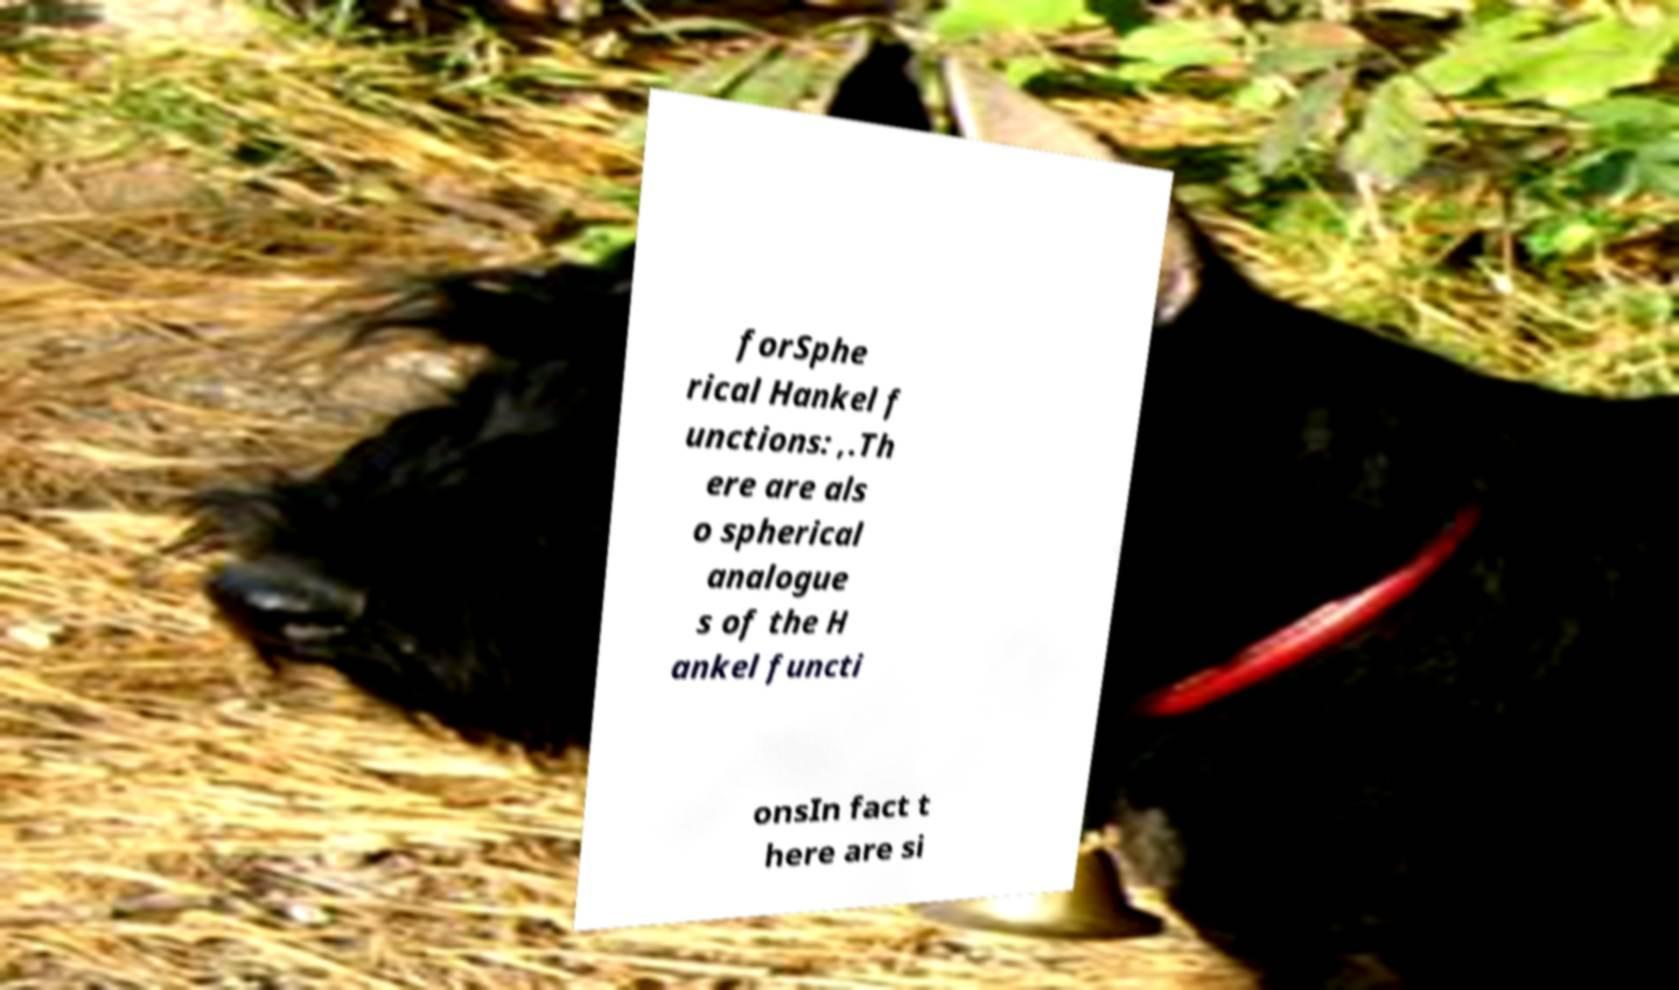For documentation purposes, I need the text within this image transcribed. Could you provide that? forSphe rical Hankel f unctions: ,.Th ere are als o spherical analogue s of the H ankel functi onsIn fact t here are si 